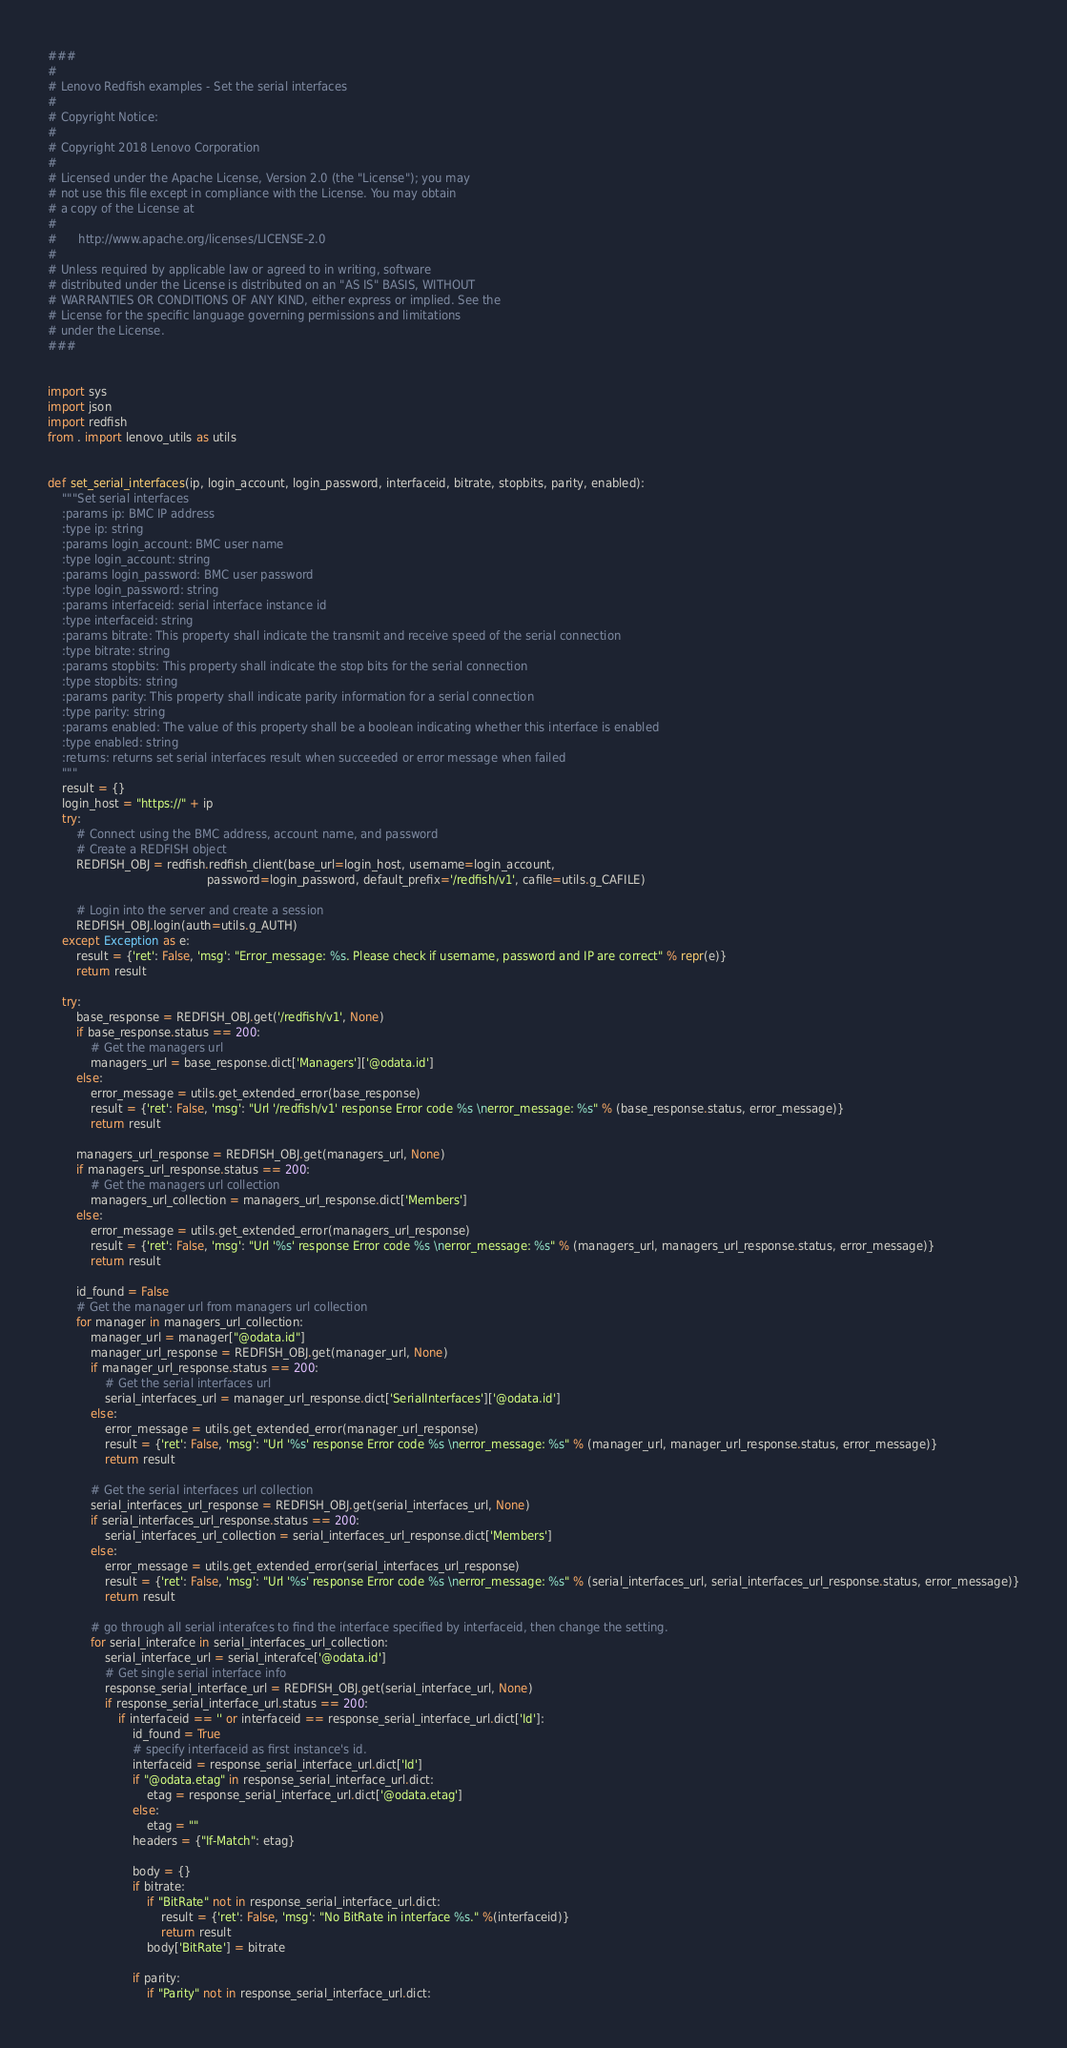Convert code to text. <code><loc_0><loc_0><loc_500><loc_500><_Python_>###
#
# Lenovo Redfish examples - Set the serial interfaces
#
# Copyright Notice:
#
# Copyright 2018 Lenovo Corporation
#
# Licensed under the Apache License, Version 2.0 (the "License"); you may
# not use this file except in compliance with the License. You may obtain
# a copy of the License at
#
#      http://www.apache.org/licenses/LICENSE-2.0
#
# Unless required by applicable law or agreed to in writing, software
# distributed under the License is distributed on an "AS IS" BASIS, WITHOUT
# WARRANTIES OR CONDITIONS OF ANY KIND, either express or implied. See the
# License for the specific language governing permissions and limitations
# under the License.
###


import sys
import json
import redfish
from . import lenovo_utils as utils


def set_serial_interfaces(ip, login_account, login_password, interfaceid, bitrate, stopbits, parity, enabled):
    """Set serial interfaces
    :params ip: BMC IP address
    :type ip: string
    :params login_account: BMC user name
    :type login_account: string
    :params login_password: BMC user password
    :type login_password: string
    :params interfaceid: serial interface instance id
    :type interfaceid: string
    :params bitrate: This property shall indicate the transmit and receive speed of the serial connection
    :type bitrate: string
    :params stopbits: This property shall indicate the stop bits for the serial connection
    :type stopbits: string
    :params parity: This property shall indicate parity information for a serial connection
    :type parity: string
    :params enabled: The value of this property shall be a boolean indicating whether this interface is enabled
    :type enabled: string
    :returns: returns set serial interfaces result when succeeded or error message when failed
    """
    result = {}
    login_host = "https://" + ip
    try:
        # Connect using the BMC address, account name, and password
        # Create a REDFISH object
        REDFISH_OBJ = redfish.redfish_client(base_url=login_host, username=login_account,
                                             password=login_password, default_prefix='/redfish/v1', cafile=utils.g_CAFILE)
    
        # Login into the server and create a session
        REDFISH_OBJ.login(auth=utils.g_AUTH)
    except Exception as e:
        result = {'ret': False, 'msg': "Error_message: %s. Please check if username, password and IP are correct" % repr(e)}
        return result
        
    try:
        base_response = REDFISH_OBJ.get('/redfish/v1', None)
        if base_response.status == 200:
            # Get the managers url
            managers_url = base_response.dict['Managers']['@odata.id']
        else:
            error_message = utils.get_extended_error(base_response)
            result = {'ret': False, 'msg': "Url '/redfish/v1' response Error code %s \nerror_message: %s" % (base_response.status, error_message)}
            return result

        managers_url_response = REDFISH_OBJ.get(managers_url, None)
        if managers_url_response.status == 200:
            # Get the managers url collection
            managers_url_collection = managers_url_response.dict['Members']
        else:
            error_message = utils.get_extended_error(managers_url_response)
            result = {'ret': False, 'msg': "Url '%s' response Error code %s \nerror_message: %s" % (managers_url, managers_url_response.status, error_message)}
            return result

        id_found = False
        # Get the manager url from managers url collection
        for manager in managers_url_collection:
            manager_url = manager["@odata.id"]
            manager_url_response = REDFISH_OBJ.get(manager_url, None)
            if manager_url_response.status == 200:
                # Get the serial interfaces url
                serial_interfaces_url = manager_url_response.dict['SerialInterfaces']['@odata.id']
            else:
                error_message = utils.get_extended_error(manager_url_response)
                result = {'ret': False, 'msg': "Url '%s' response Error code %s \nerror_message: %s" % (manager_url, manager_url_response.status, error_message)}
                return result

            # Get the serial interfaces url collection
            serial_interfaces_url_response = REDFISH_OBJ.get(serial_interfaces_url, None)
            if serial_interfaces_url_response.status == 200:
                serial_interfaces_url_collection = serial_interfaces_url_response.dict['Members']
            else:
                error_message = utils.get_extended_error(serial_interfaces_url_response)
                result = {'ret': False, 'msg': "Url '%s' response Error code %s \nerror_message: %s" % (serial_interfaces_url, serial_interfaces_url_response.status, error_message)}
                return result

            # go through all serial interafces to find the interface specified by interfaceid, then change the setting.
            for serial_interafce in serial_interfaces_url_collection:
                serial_interface_url = serial_interafce['@odata.id']
                # Get single serial interface info
                response_serial_interface_url = REDFISH_OBJ.get(serial_interface_url, None)
                if response_serial_interface_url.status == 200:
                    if interfaceid == '' or interfaceid == response_serial_interface_url.dict['Id']:
                        id_found = True
                        # specify interfaceid as first instance's id.
                        interfaceid = response_serial_interface_url.dict['Id']
                        if "@odata.etag" in response_serial_interface_url.dict:
                            etag = response_serial_interface_url.dict['@odata.etag']
                        else:
                            etag = ""
                        headers = {"If-Match": etag}

                        body = {}
                        if bitrate:
                            if "BitRate" not in response_serial_interface_url.dict:
                                result = {'ret': False, 'msg': "No BitRate in interface %s." %(interfaceid)}
                                return result
                            body['BitRate'] = bitrate

                        if parity:
                            if "Parity" not in response_serial_interface_url.dict:</code> 